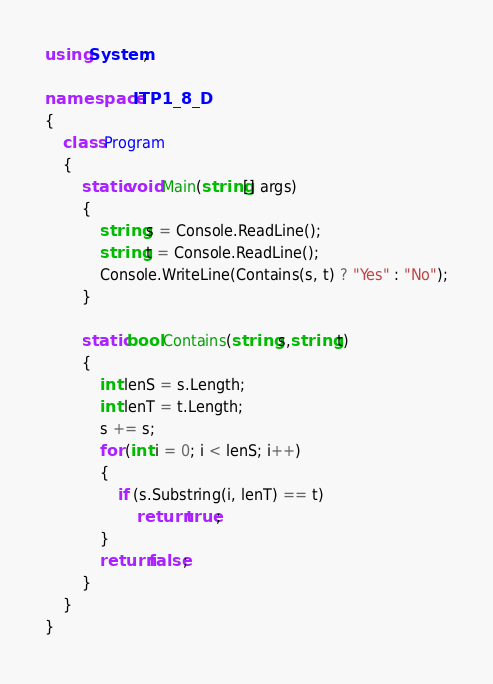<code> <loc_0><loc_0><loc_500><loc_500><_C#_>using System;

namespace ITP1_8_D
{
    class Program
    {
        static void Main(string[] args)
        {
            string s = Console.ReadLine();
            string t = Console.ReadLine();
            Console.WriteLine(Contains(s, t) ? "Yes" : "No");
        }

        static bool Contains(string s,string t)
        {
            int lenS = s.Length;
            int lenT = t.Length;
            s += s;
            for (int i = 0; i < lenS; i++)
            {
                if (s.Substring(i, lenT) == t)
                    return true;
            }
            return false;
        }
    }
}</code> 